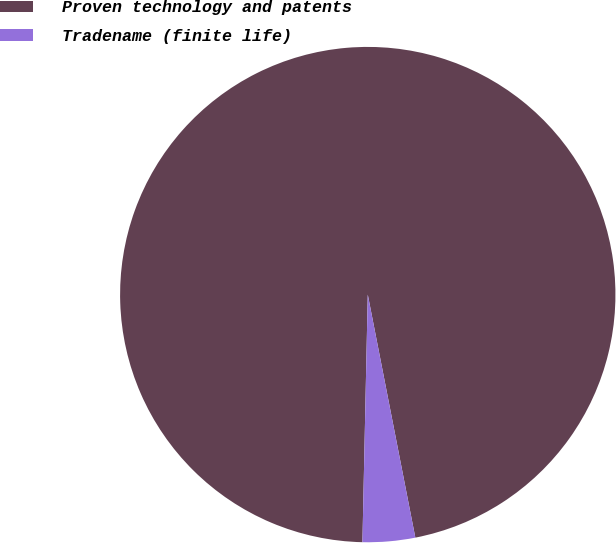Convert chart to OTSL. <chart><loc_0><loc_0><loc_500><loc_500><pie_chart><fcel>Proven technology and patents<fcel>Tradename (finite life)<nl><fcel>96.58%<fcel>3.42%<nl></chart> 